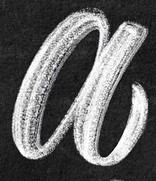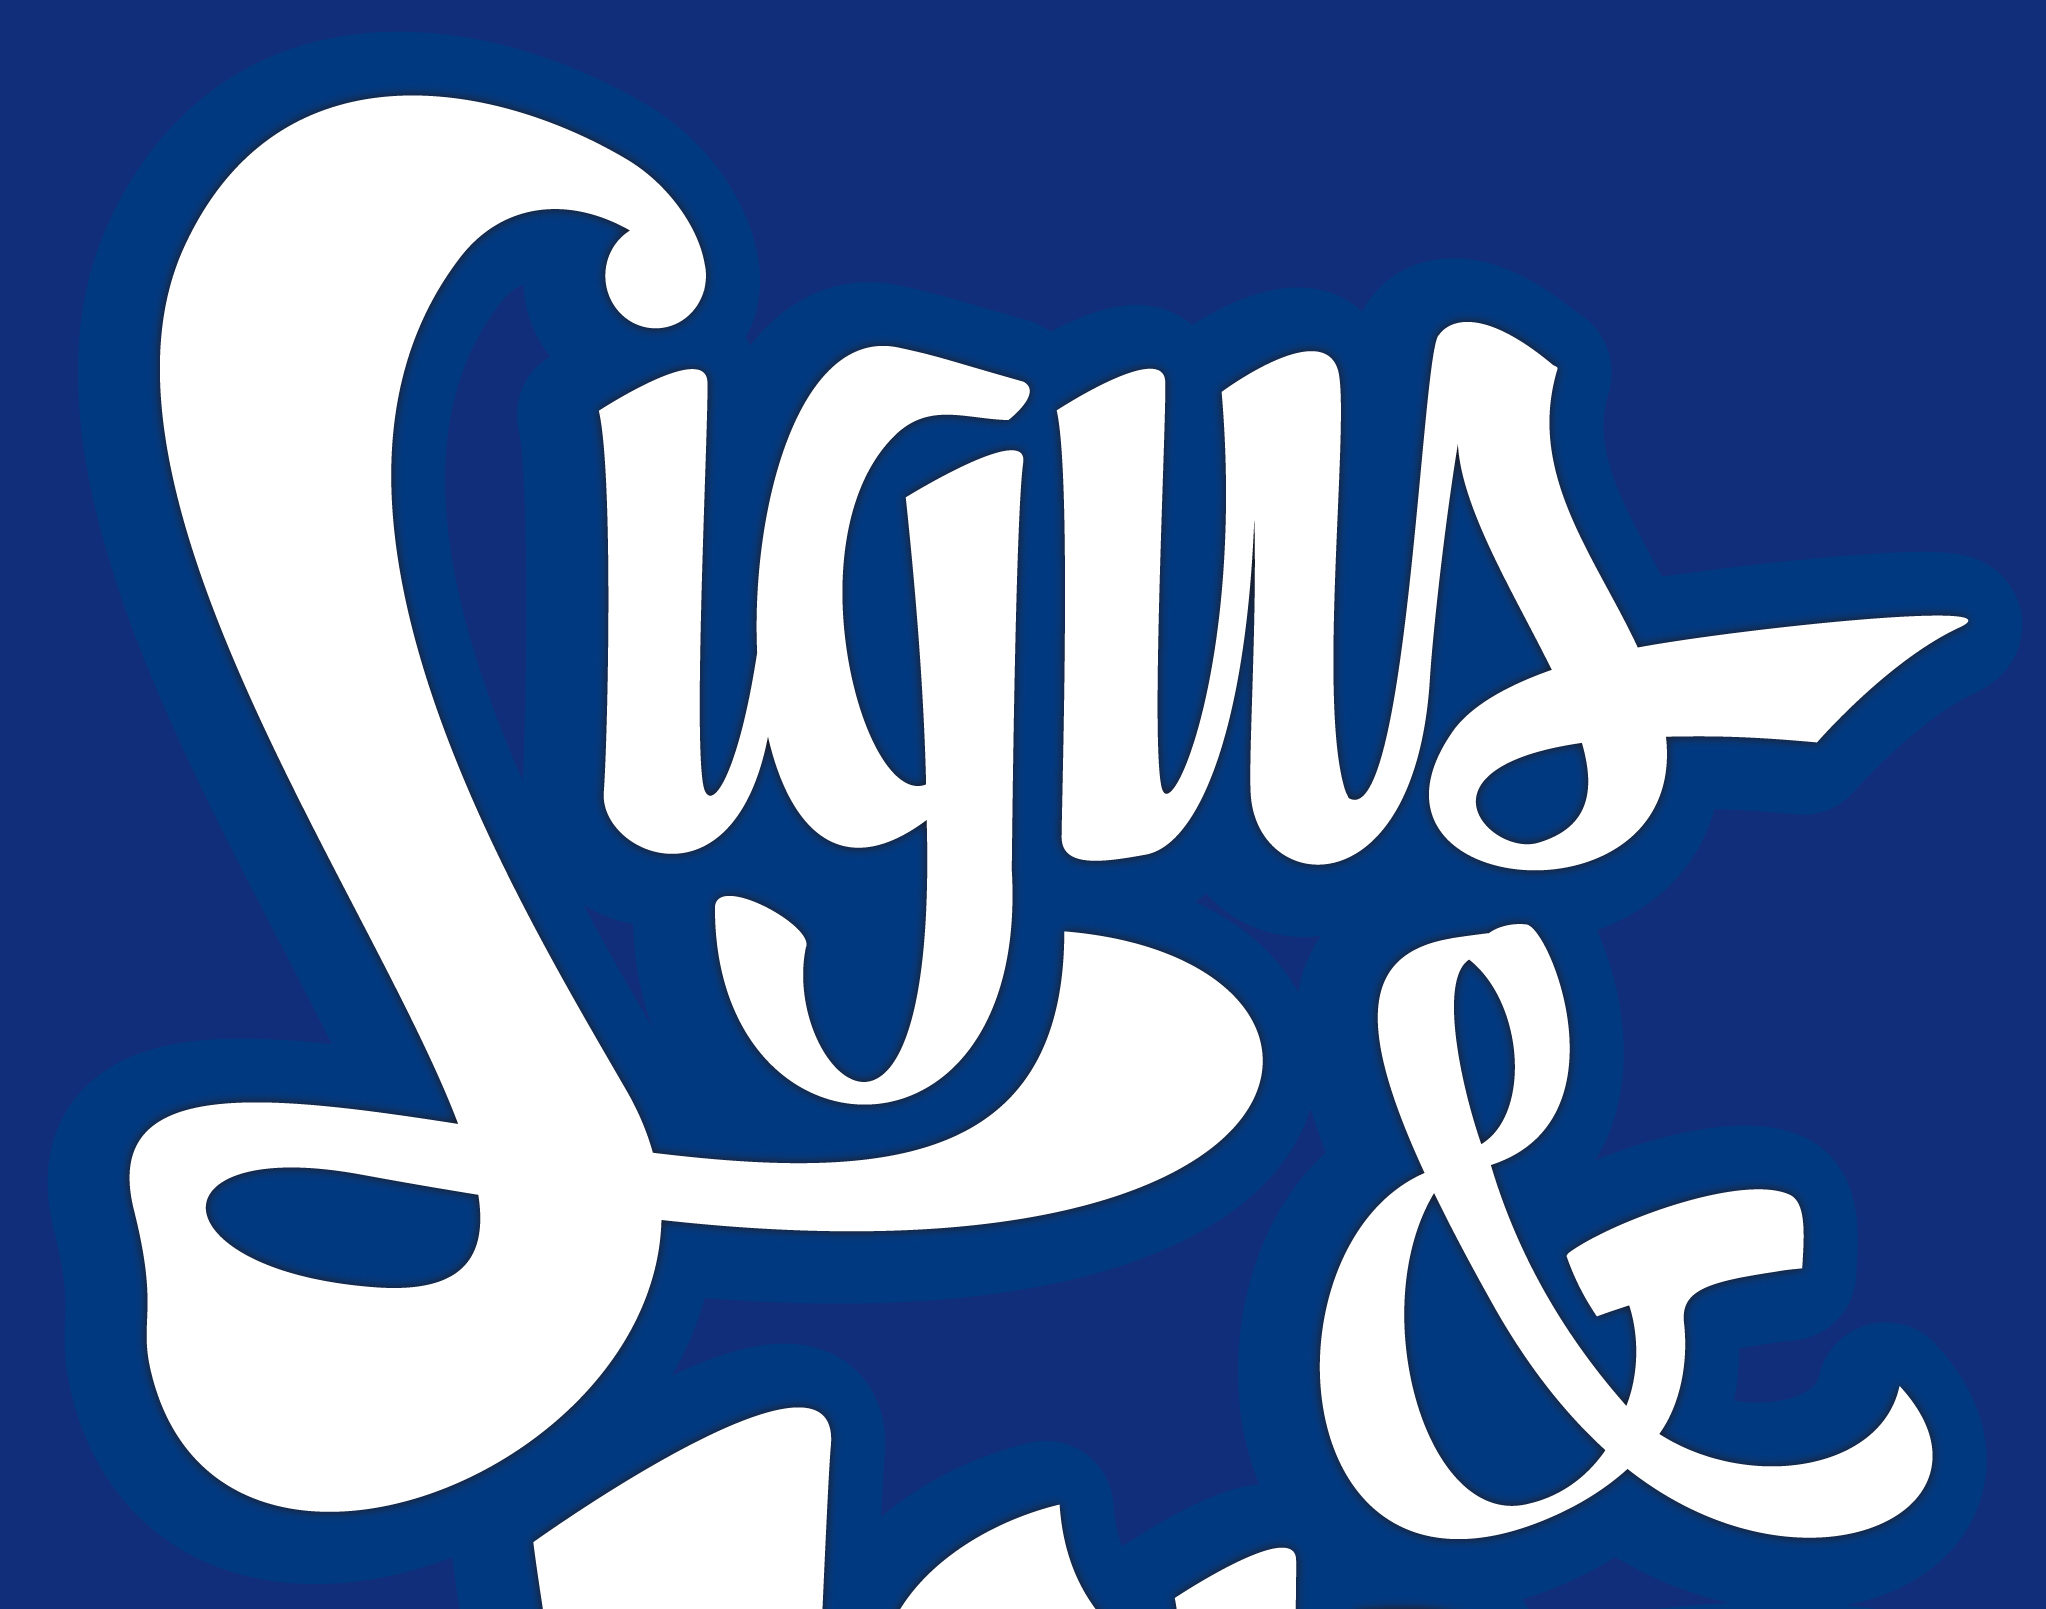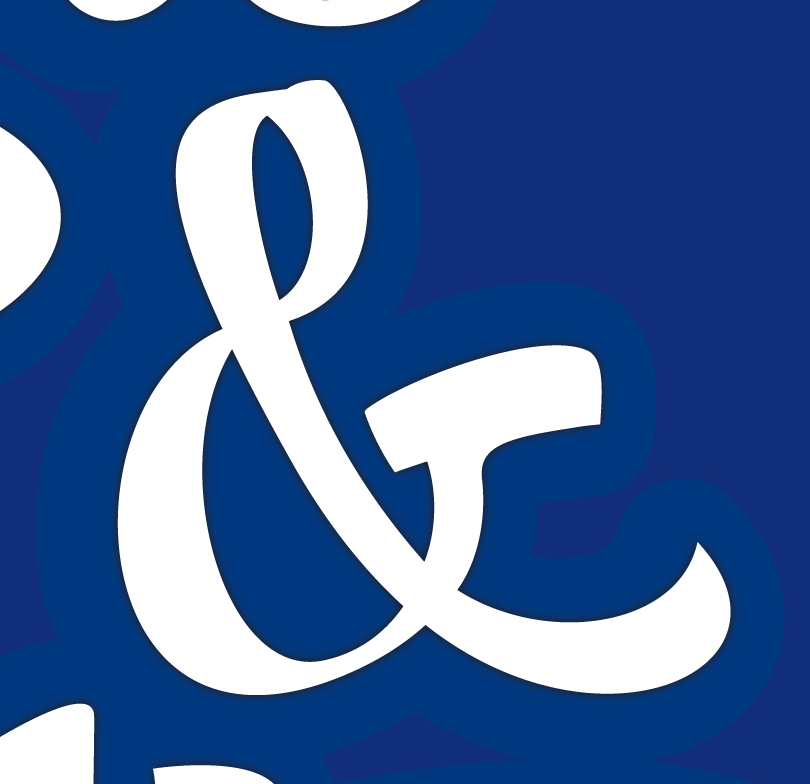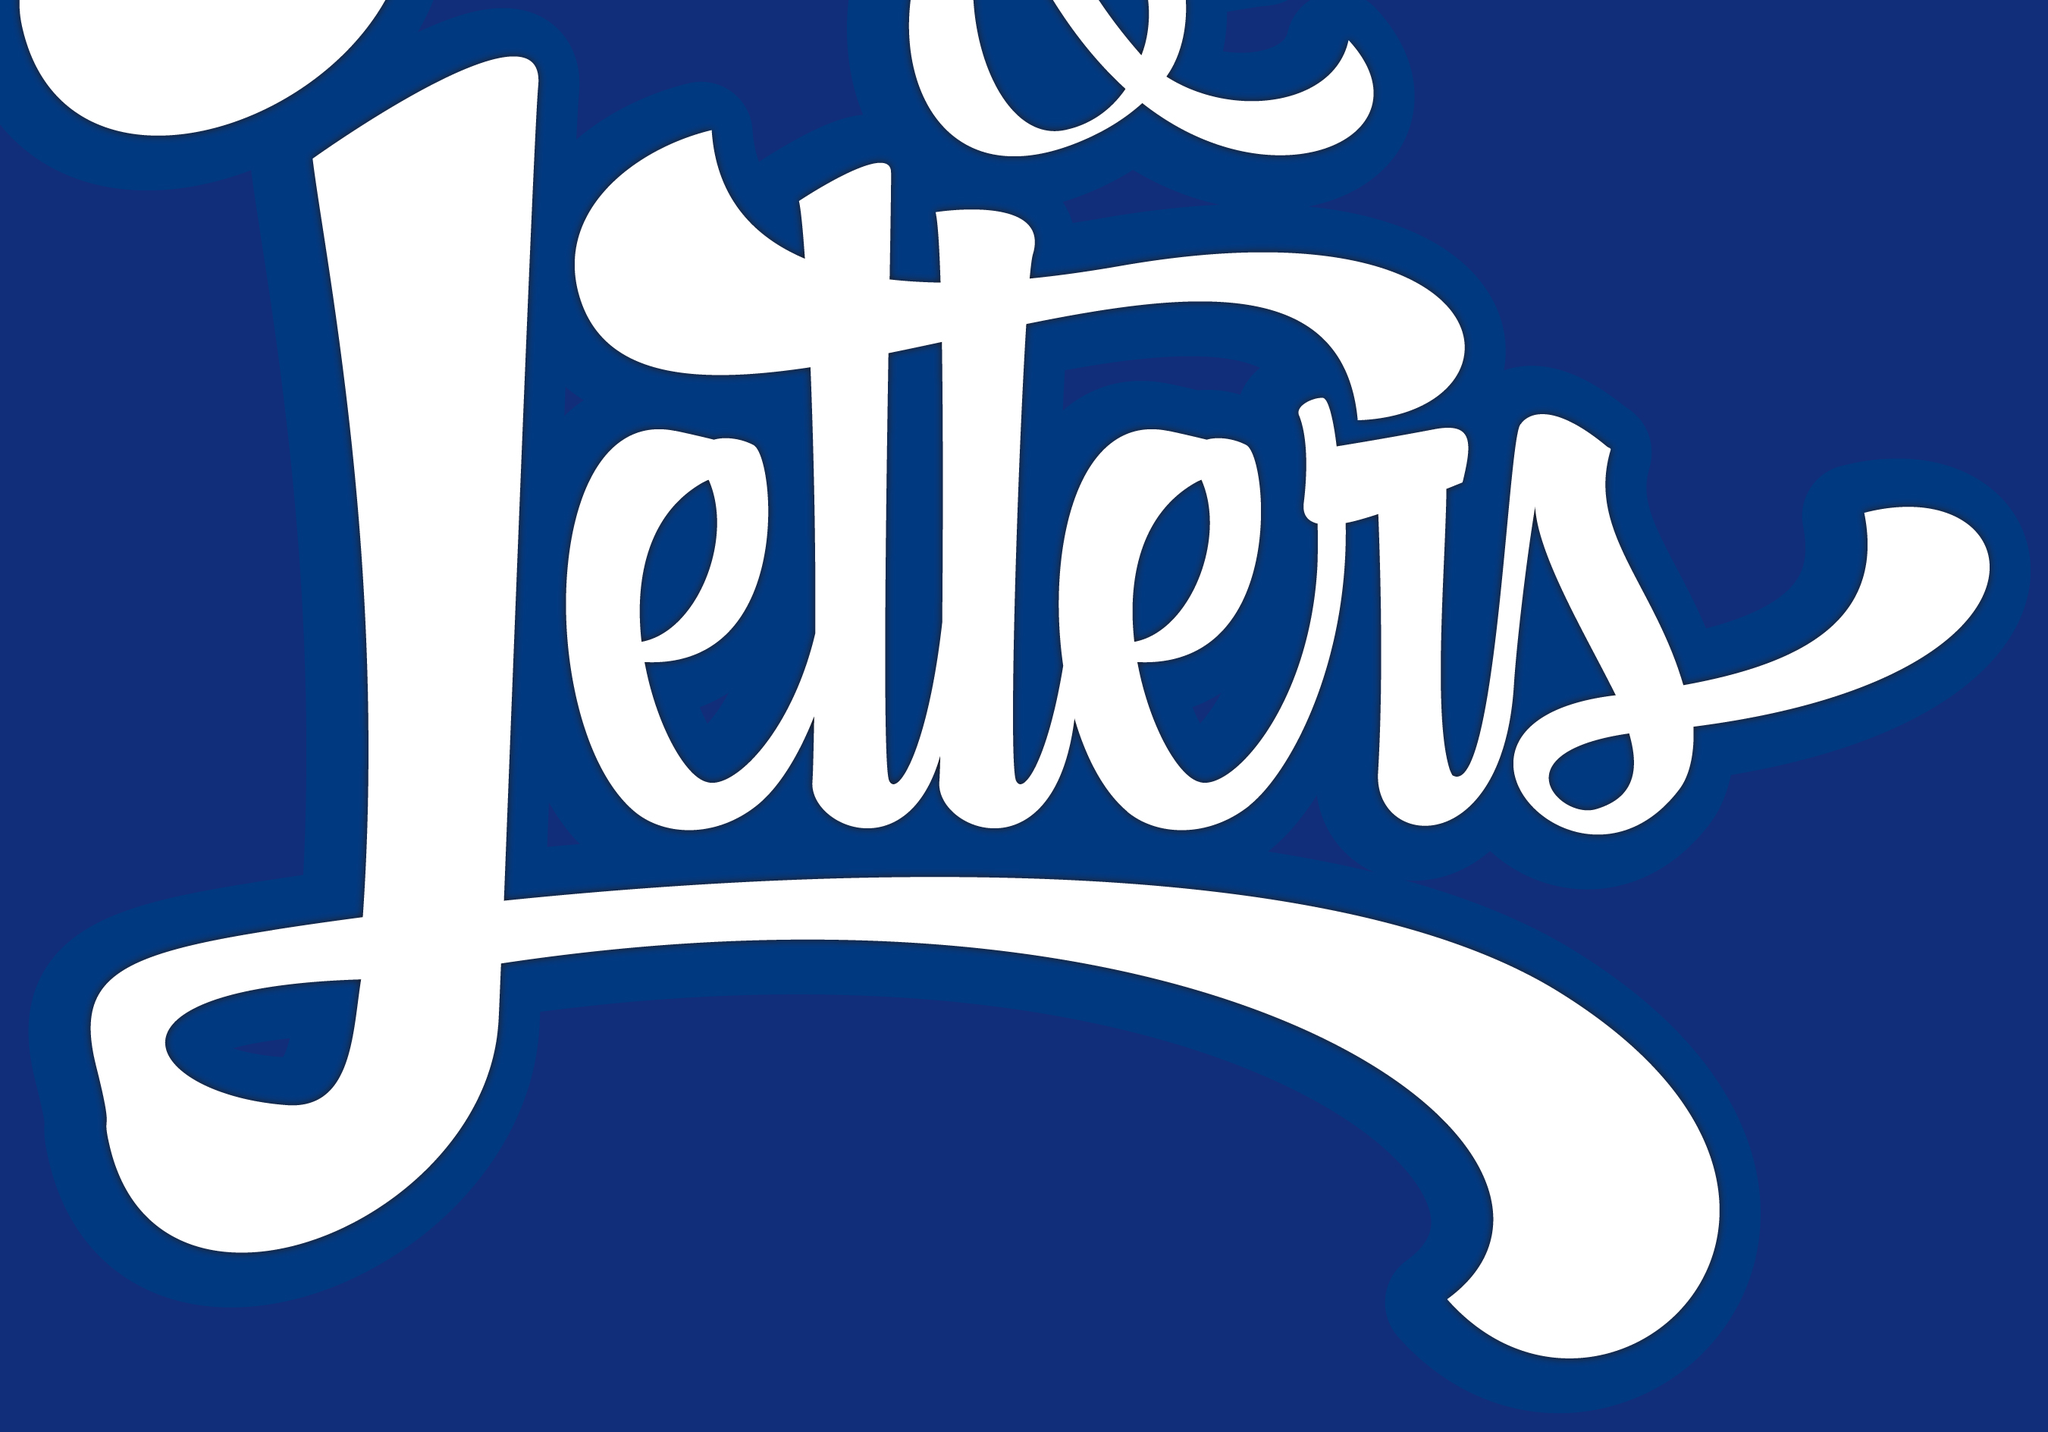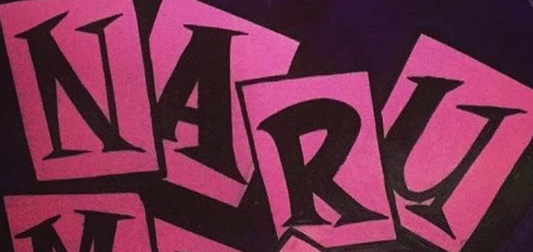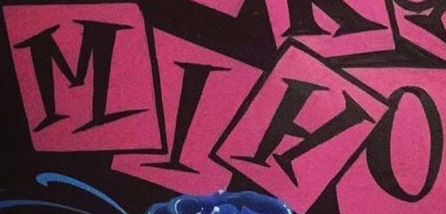Read the text content from these images in order, separated by a semicolon. a; Signs; &; Letters; NARU; MIHO 